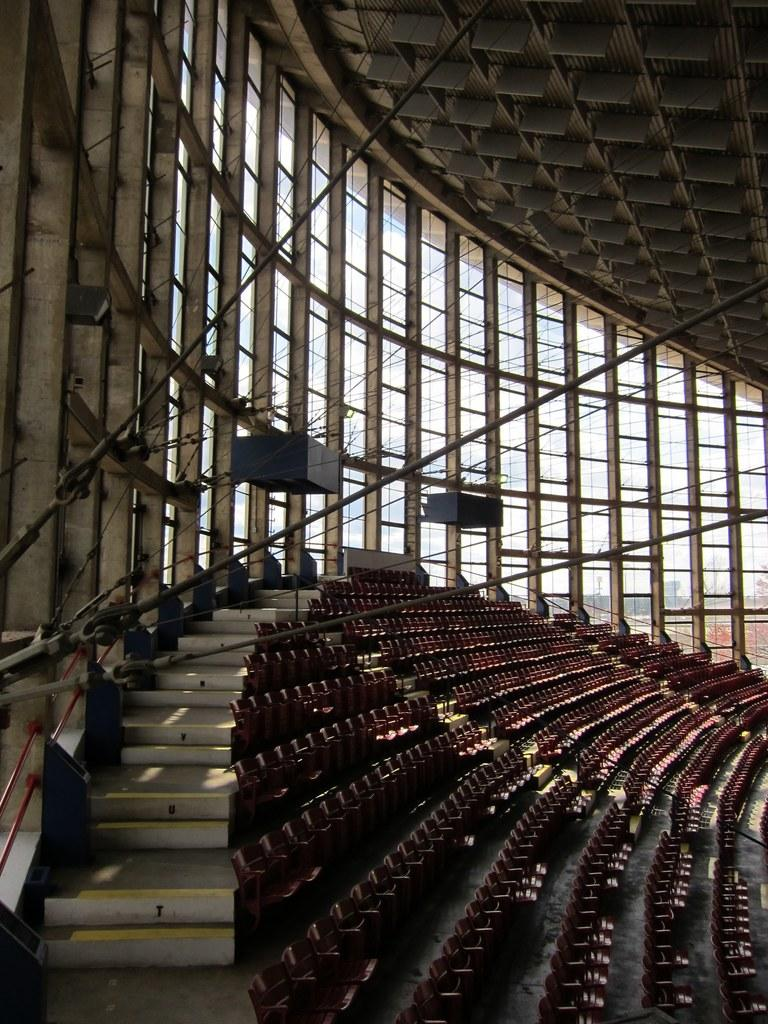What type of furniture is present in the image? There is a group of chairs in the image. What other objects can be seen in the image? There are rods, steps, and glass windows in the image. What is visible through the glass windows? The sky is visible through the windows. What time of day is indicated by the hour on the clock in the image? There is no clock present in the image, so we cannot determine the time of day. 